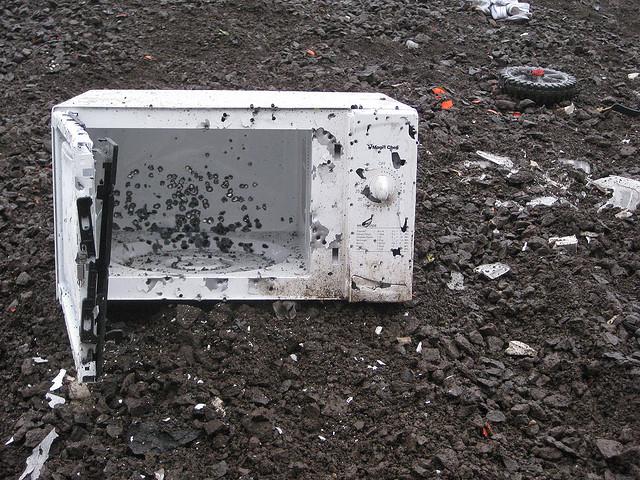Is this area clean?
Keep it brief. No. Is the microwave broken?
Write a very short answer. Yes. What kind of appliance is shown?
Give a very brief answer. Microwave. 